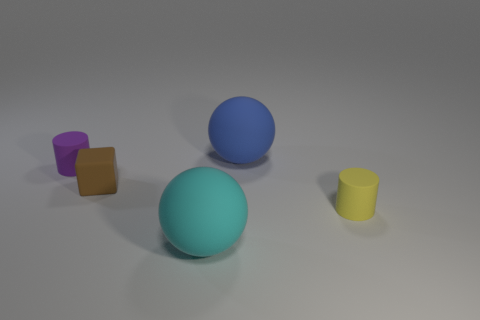Subtract all cubes. How many objects are left? 4 Add 2 green metal cylinders. How many objects exist? 7 Subtract all purple cylinders. How many cylinders are left? 1 Subtract 1 cubes. How many cubes are left? 0 Subtract all purple balls. Subtract all cyan cylinders. How many balls are left? 2 Subtract all gray cylinders. How many blue spheres are left? 1 Subtract all cyan spheres. Subtract all cyan spheres. How many objects are left? 3 Add 1 brown things. How many brown things are left? 2 Add 3 tiny yellow cylinders. How many tiny yellow cylinders exist? 4 Subtract 0 cyan cubes. How many objects are left? 5 